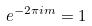<formula> <loc_0><loc_0><loc_500><loc_500>e ^ { - 2 \pi i m } = 1</formula> 